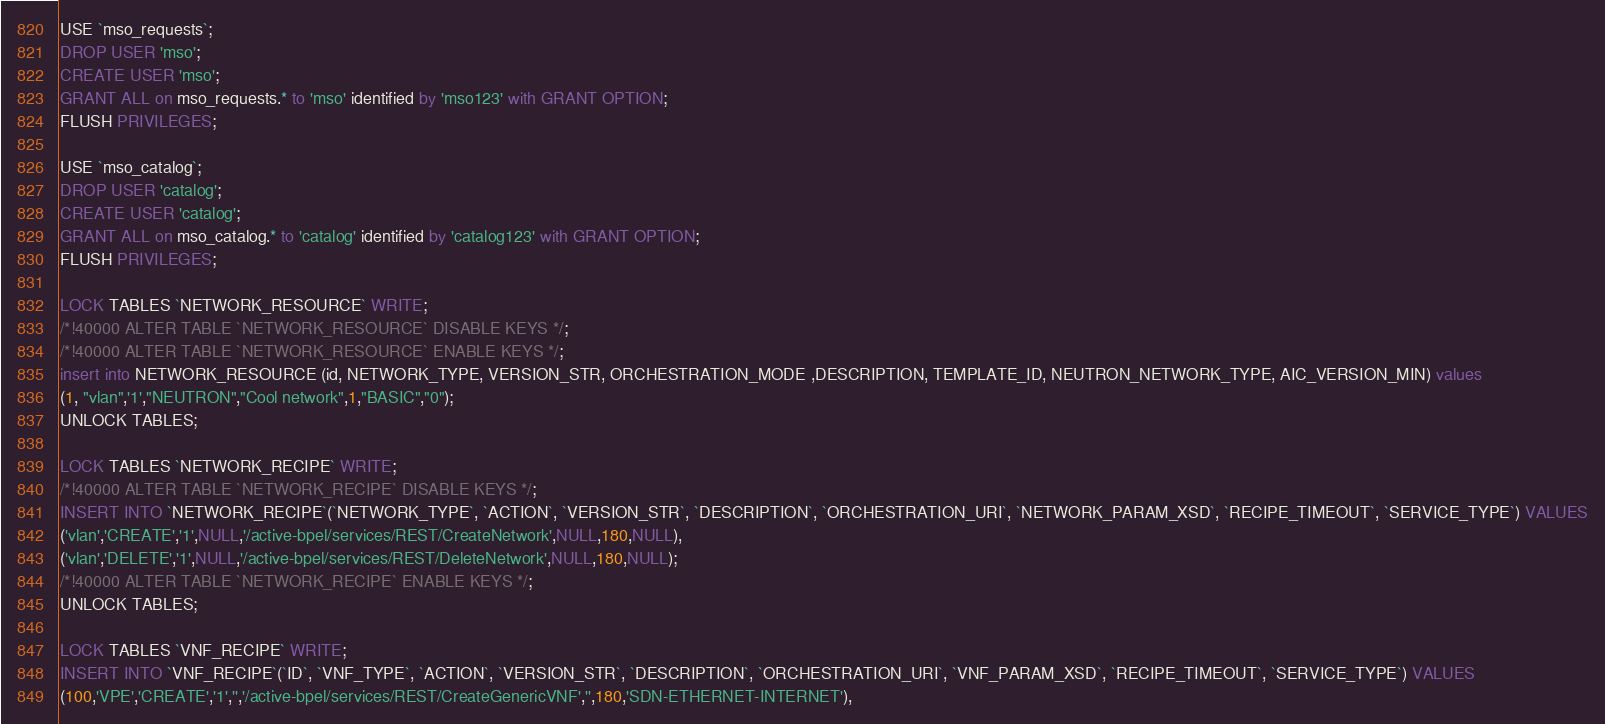<code> <loc_0><loc_0><loc_500><loc_500><_SQL_>USE `mso_requests`;
DROP USER 'mso';
CREATE USER 'mso';
GRANT ALL on mso_requests.* to 'mso' identified by 'mso123' with GRANT OPTION;
FLUSH PRIVILEGES;

USE `mso_catalog`;
DROP USER 'catalog';
CREATE USER 'catalog';
GRANT ALL on mso_catalog.* to 'catalog' identified by 'catalog123' with GRANT OPTION;
FLUSH PRIVILEGES;

LOCK TABLES `NETWORK_RESOURCE` WRITE;
/*!40000 ALTER TABLE `NETWORK_RESOURCE` DISABLE KEYS */;
/*!40000 ALTER TABLE `NETWORK_RESOURCE` ENABLE KEYS */;
insert into NETWORK_RESOURCE (id, NETWORK_TYPE, VERSION_STR, ORCHESTRATION_MODE ,DESCRIPTION, TEMPLATE_ID, NEUTRON_NETWORK_TYPE, AIC_VERSION_MIN) values
(1, "vlan",'1',"NEUTRON","Cool network",1,"BASIC","0");
UNLOCK TABLES;

LOCK TABLES `NETWORK_RECIPE` WRITE;
/*!40000 ALTER TABLE `NETWORK_RECIPE` DISABLE KEYS */;
INSERT INTO `NETWORK_RECIPE`(`NETWORK_TYPE`, `ACTION`, `VERSION_STR`, `DESCRIPTION`, `ORCHESTRATION_URI`, `NETWORK_PARAM_XSD`, `RECIPE_TIMEOUT`, `SERVICE_TYPE`) VALUES
('vlan','CREATE','1',NULL,'/active-bpel/services/REST/CreateNetwork',NULL,180,NULL),
('vlan','DELETE','1',NULL,'/active-bpel/services/REST/DeleteNetwork',NULL,180,NULL);
/*!40000 ALTER TABLE `NETWORK_RECIPE` ENABLE KEYS */;
UNLOCK TABLES;

LOCK TABLES `VNF_RECIPE` WRITE;
INSERT INTO `VNF_RECIPE`(`ID`, `VNF_TYPE`, `ACTION`, `VERSION_STR`, `DESCRIPTION`, `ORCHESTRATION_URI`, `VNF_PARAM_XSD`, `RECIPE_TIMEOUT`, `SERVICE_TYPE`) VALUES
(100,'VPE','CREATE','1','','/active-bpel/services/REST/CreateGenericVNF','',180,'SDN-ETHERNET-INTERNET'),</code> 